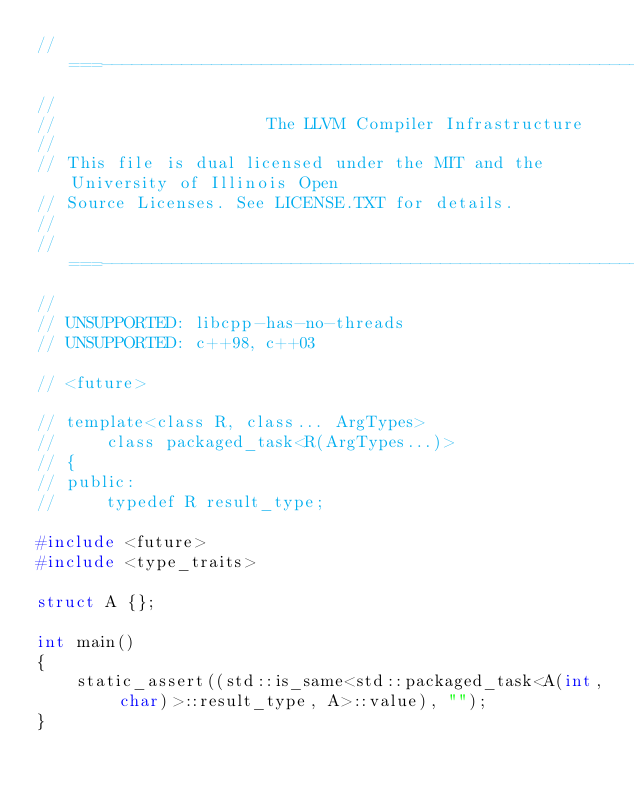Convert code to text. <code><loc_0><loc_0><loc_500><loc_500><_C++_>//===----------------------------------------------------------------------===//
//
//                     The LLVM Compiler Infrastructure
//
// This file is dual licensed under the MIT and the University of Illinois Open
// Source Licenses. See LICENSE.TXT for details.
//
//===----------------------------------------------------------------------===//
//
// UNSUPPORTED: libcpp-has-no-threads
// UNSUPPORTED: c++98, c++03

// <future>

// template<class R, class... ArgTypes>
//     class packaged_task<R(ArgTypes...)>
// {
// public:
//     typedef R result_type;

#include <future>
#include <type_traits>

struct A {};

int main()
{
    static_assert((std::is_same<std::packaged_task<A(int, char)>::result_type, A>::value), "");
}
</code> 